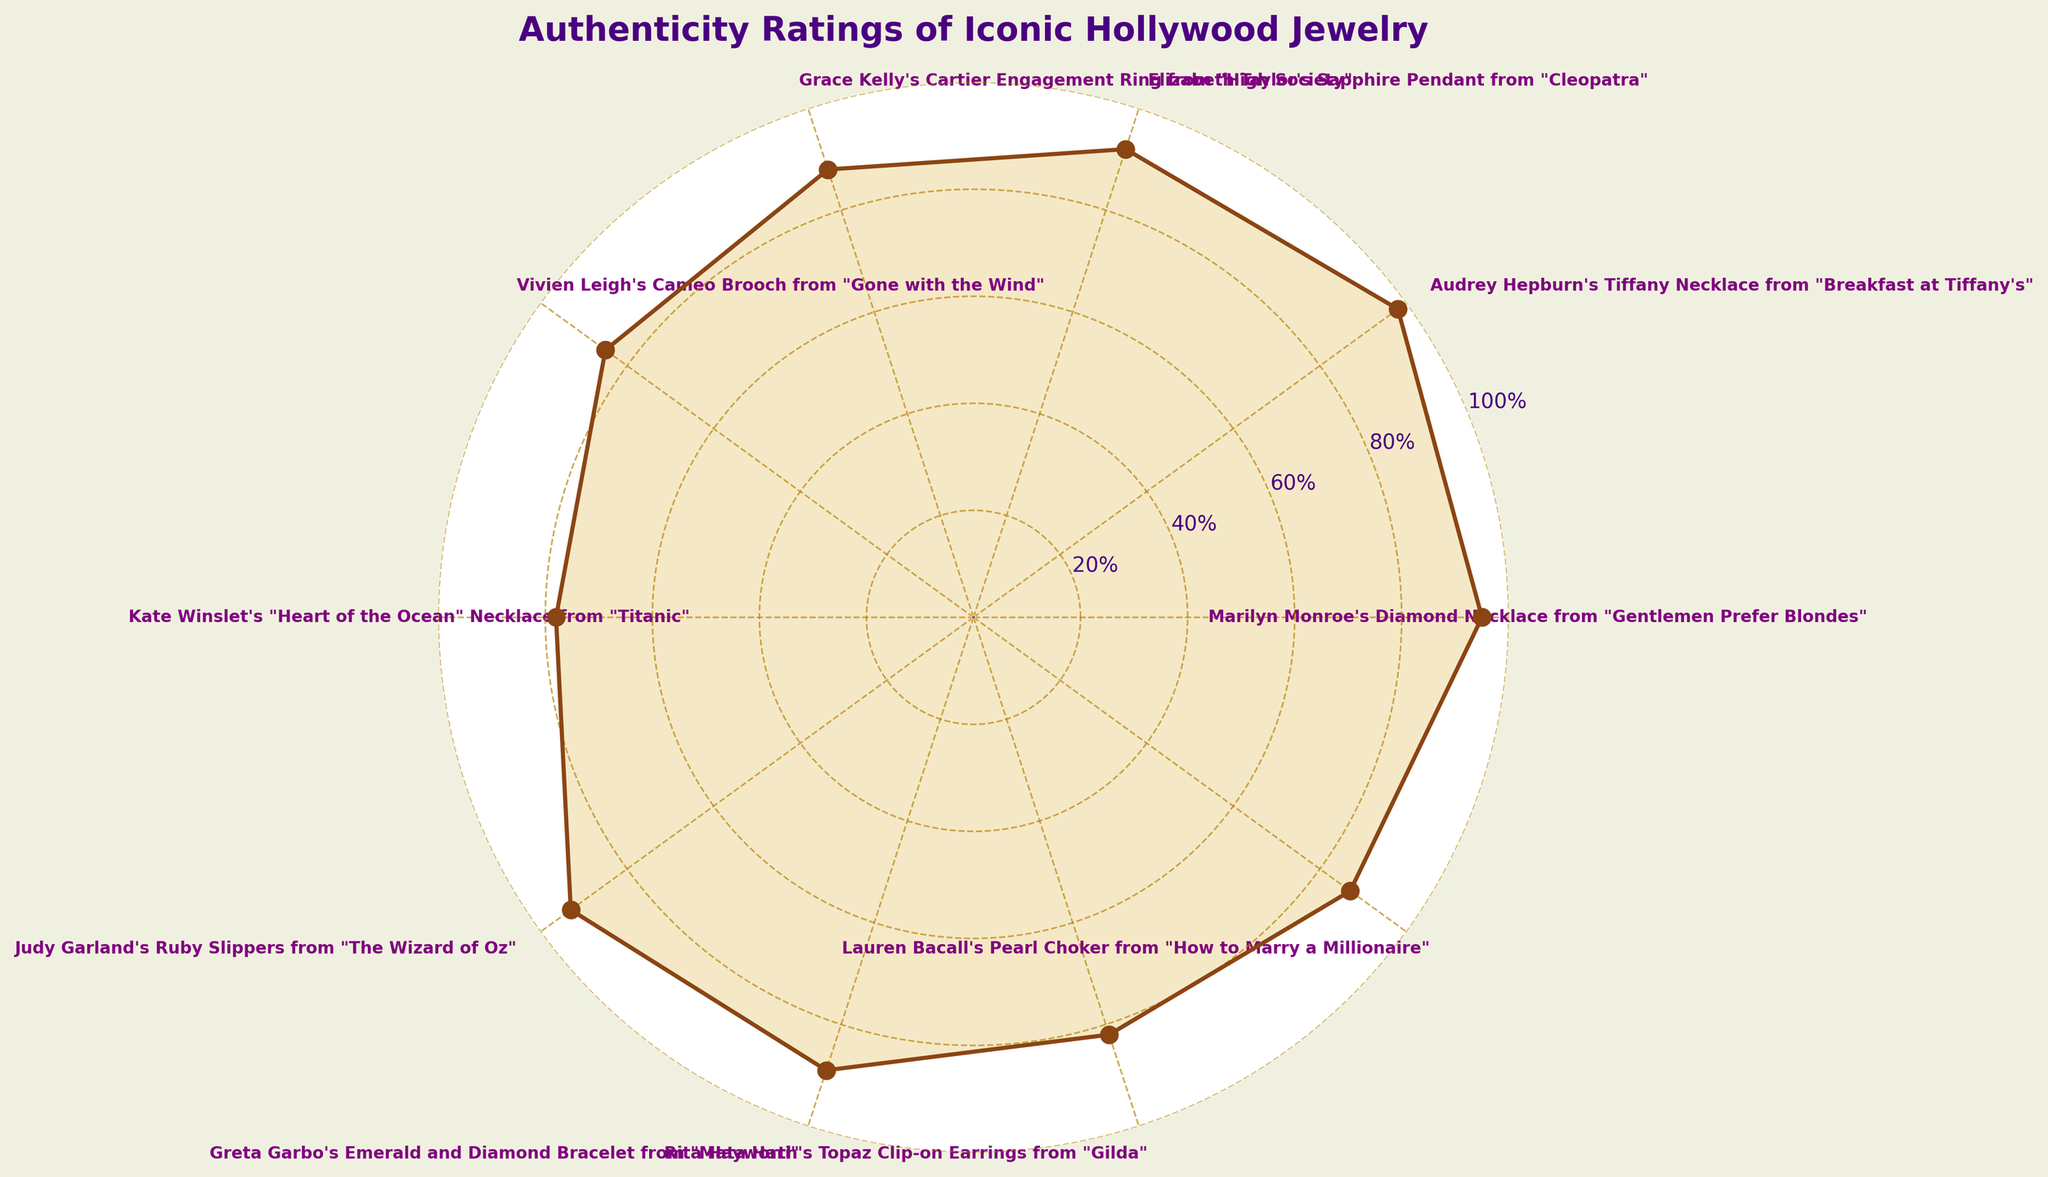What is the title of the plot? The title of the plot is located at the top of the figure.
Answer: Authenticity Ratings of Iconic Hollywood Jewelry Which jewelry piece has the highest authenticity rating? By inspecting the plot, the jewelry piece with the highest value on the radial axis is the one with a rating of 98.
Answer: Audrey Hepburn's Tiffany Necklace from "Breakfast at Tiffany's" How many jewelry pieces have an authenticity rating of 90 or above? Count the data points where the rating is 90 or above by looking at the radial axis.
Answer: 4 What is the smallest authenticity rating displayed? Look for the point closest to the center of the circular plot.
Answer: 78 Which jewelry pieces have ratings between 80 and 90? Identify the segments that fall within the radial range of 80%-90%.
Answer: Grace Kelly's Cartier Engagement Ring from "High Society", Vivien Leigh's Cameo Brooch from "Gone with the Wind", Greta Garbo's Emerald and Diamond Bracelet from "Mata Hari", Rita Hayworth's Topaz Clip-on Earrings from "Gilda", Lauren Bacall's Pearl Choker from "How to Marry a Millionaire" What is the average authenticity rating of all the jewelry pieces? Sum all the authenticity ratings and divide by the number of jewelry pieces: (95 + 98 + 92 + 88 + 85 + 78 + 93 + 89 + 82 + 87) / 10.
Answer: 88.7 How does the authenticity rating of Judy Garland's Ruby Slippers compare to that of Elizabeth Taylor's Sapphire Pendant? Compare the authenticity ratings of both jewelry pieces directly from the figure.
Answer: Judy Garland's Ruby Slippers have a higher rating (93 vs 92) Which jewelry piece has a rating closest to the average rating? Calculate the average rating as 88.7, then find the piece whose rating is nearest to this value.
Answer: Lauren Bacall's Pearl Choker from "How to Marry a Millionaire" (87) What is the total number of unique jewelry pieces displayed in the plot? Count the number of distinct data points listed in the plot.
Answer: 10 How does Greta Garbo's Emerald and Diamond Bracelet rating differ from Kate Winslet's "Heart of the Ocean" Necklace? Subtract the rating of Kate Winslet's necklace from Greta Garbo's bracelet.
Answer: 89 - 78 = 11 Which jewelry piece worn by a star has the lowest authenticity rating from a movie released in the 1960s? Identify movies from the 1960s and check their corresponding ratings.
Answer: Rita Hayworth's Topaz Clip-on Earrings from "Gilda" 